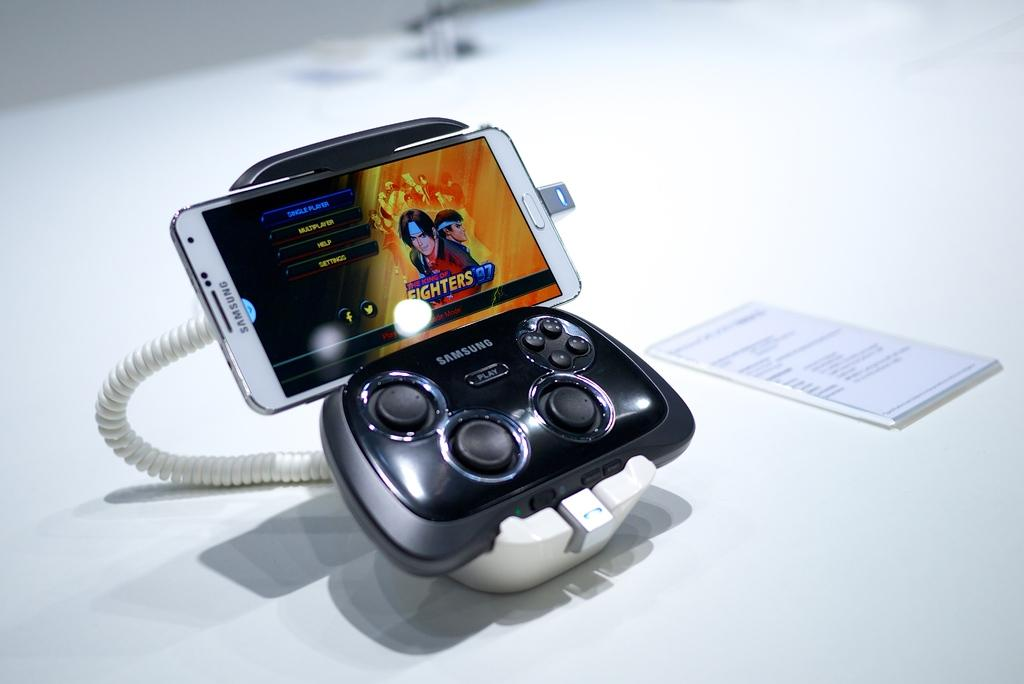<image>
Relay a brief, clear account of the picture shown. A samsung gaming system shows The King of Fighters '97 on the phone screen 